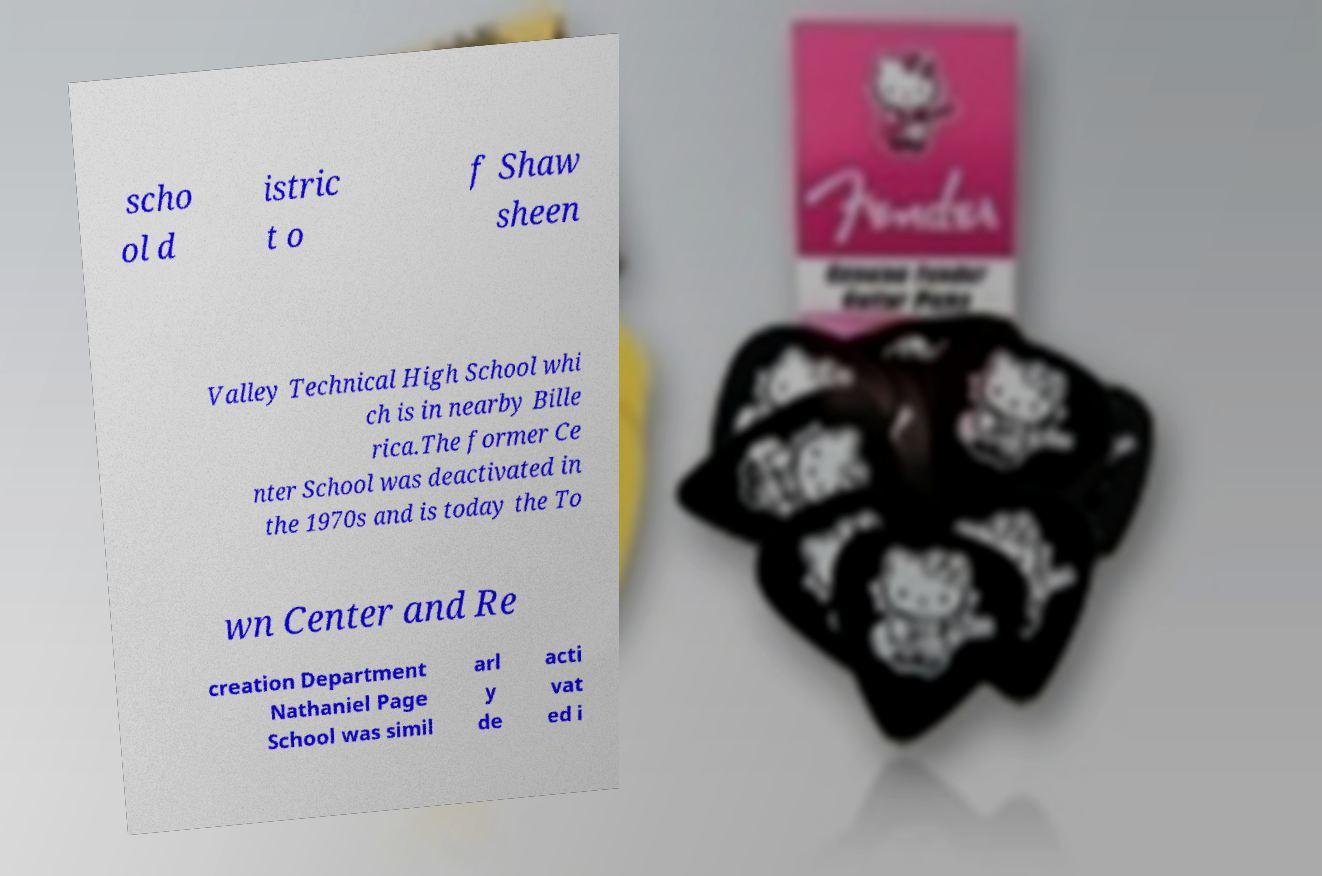Please identify and transcribe the text found in this image. scho ol d istric t o f Shaw sheen Valley Technical High School whi ch is in nearby Bille rica.The former Ce nter School was deactivated in the 1970s and is today the To wn Center and Re creation Department Nathaniel Page School was simil arl y de acti vat ed i 